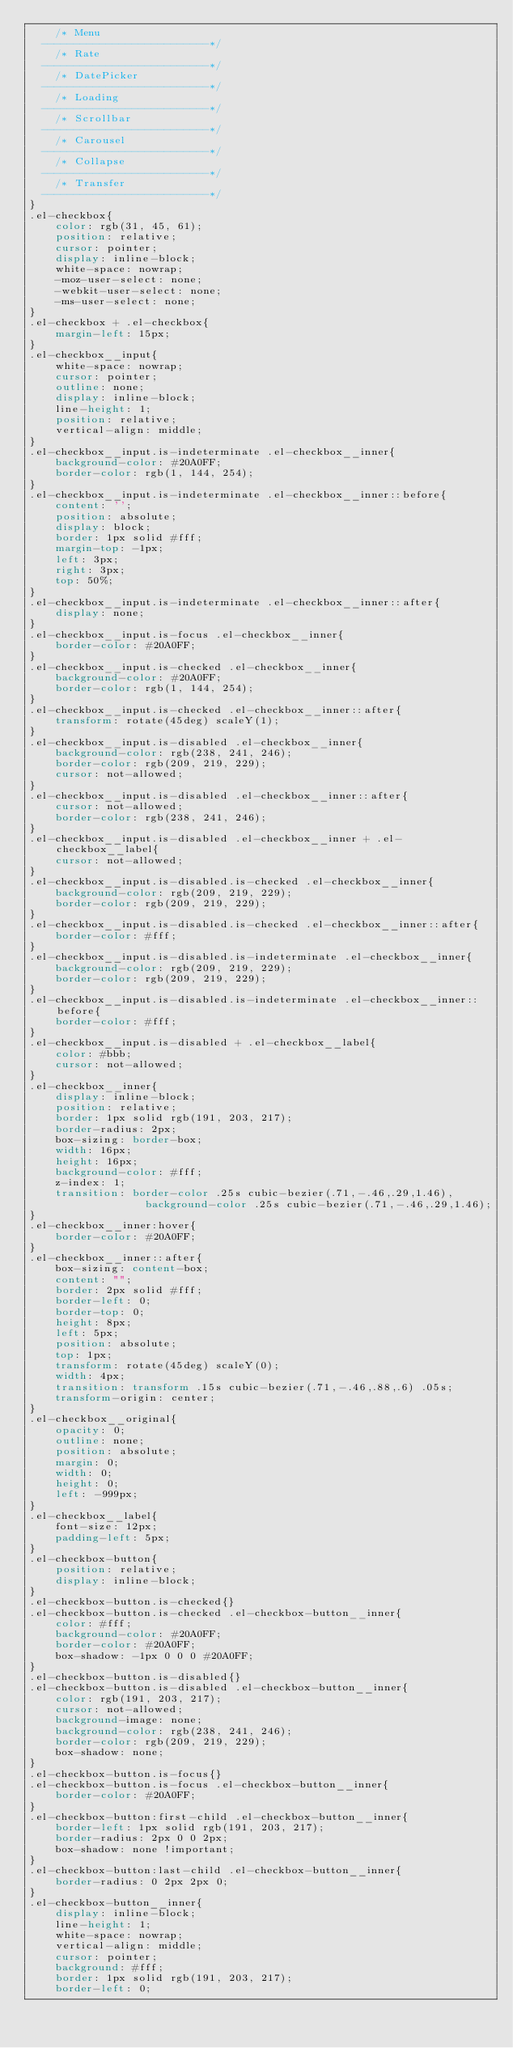<code> <loc_0><loc_0><loc_500><loc_500><_CSS_>    /* Menu
  --------------------------*/
    /* Rate
  --------------------------*/
    /* DatePicker
  --------------------------*/
    /* Loading
  --------------------------*/
    /* Scrollbar
  --------------------------*/
    /* Carousel
  --------------------------*/
    /* Collapse
  --------------------------*/
    /* Transfer
  --------------------------*/
}
.el-checkbox{
    color: rgb(31, 45, 61);
    position: relative;
    cursor: pointer;
    display: inline-block;
    white-space: nowrap;
    -moz-user-select: none;
    -webkit-user-select: none;
    -ms-user-select: none;
}
.el-checkbox + .el-checkbox{
    margin-left: 15px;
}
.el-checkbox__input{
    white-space: nowrap;
    cursor: pointer;
    outline: none;
    display: inline-block;
    line-height: 1;
    position: relative;
    vertical-align: middle;
}
.el-checkbox__input.is-indeterminate .el-checkbox__inner{
    background-color: #20A0FF;
    border-color: rgb(1, 144, 254);
}
.el-checkbox__input.is-indeterminate .el-checkbox__inner::before{
    content: '';
    position: absolute;
    display: block;
    border: 1px solid #fff;
    margin-top: -1px;
    left: 3px;
    right: 3px;
    top: 50%;
}
.el-checkbox__input.is-indeterminate .el-checkbox__inner::after{
    display: none;
}
.el-checkbox__input.is-focus .el-checkbox__inner{
    border-color: #20A0FF;
}
.el-checkbox__input.is-checked .el-checkbox__inner{
    background-color: #20A0FF;
    border-color: rgb(1, 144, 254);
}
.el-checkbox__input.is-checked .el-checkbox__inner::after{
    transform: rotate(45deg) scaleY(1);
}
.el-checkbox__input.is-disabled .el-checkbox__inner{
    background-color: rgb(238, 241, 246);
    border-color: rgb(209, 219, 229);
    cursor: not-allowed;
}
.el-checkbox__input.is-disabled .el-checkbox__inner::after{
    cursor: not-allowed;
    border-color: rgb(238, 241, 246);
}
.el-checkbox__input.is-disabled .el-checkbox__inner + .el-checkbox__label{
    cursor: not-allowed;
}
.el-checkbox__input.is-disabled.is-checked .el-checkbox__inner{
    background-color: rgb(209, 219, 229);
    border-color: rgb(209, 219, 229);
}
.el-checkbox__input.is-disabled.is-checked .el-checkbox__inner::after{
    border-color: #fff;
}
.el-checkbox__input.is-disabled.is-indeterminate .el-checkbox__inner{
    background-color: rgb(209, 219, 229);
    border-color: rgb(209, 219, 229);
}
.el-checkbox__input.is-disabled.is-indeterminate .el-checkbox__inner::before{
    border-color: #fff;
}
.el-checkbox__input.is-disabled + .el-checkbox__label{
    color: #bbb;
    cursor: not-allowed;
}
.el-checkbox__inner{
    display: inline-block;
    position: relative;
    border: 1px solid rgb(191, 203, 217);
    border-radius: 2px;
    box-sizing: border-box;
    width: 16px;
    height: 16px;
    background-color: #fff;
    z-index: 1;
    transition: border-color .25s cubic-bezier(.71,-.46,.29,1.46),
                  background-color .25s cubic-bezier(.71,-.46,.29,1.46);
}
.el-checkbox__inner:hover{
    border-color: #20A0FF;
}
.el-checkbox__inner::after{
    box-sizing: content-box;
    content: "";
    border: 2px solid #fff;
    border-left: 0;
    border-top: 0;
    height: 8px;
    left: 5px;
    position: absolute;
    top: 1px;
    transform: rotate(45deg) scaleY(0);
    width: 4px;
    transition: transform .15s cubic-bezier(.71,-.46,.88,.6) .05s;
    transform-origin: center;
}
.el-checkbox__original{
    opacity: 0;
    outline: none;
    position: absolute;
    margin: 0;
    width: 0;
    height: 0;
    left: -999px;
}
.el-checkbox__label{
    font-size: 12px;
    padding-left: 5px;
}
.el-checkbox-button{
    position: relative;
    display: inline-block;
}
.el-checkbox-button.is-checked{}
.el-checkbox-button.is-checked .el-checkbox-button__inner{
    color: #fff;
    background-color: #20A0FF;
    border-color: #20A0FF;
    box-shadow: -1px 0 0 0 #20A0FF;
}
.el-checkbox-button.is-disabled{}
.el-checkbox-button.is-disabled .el-checkbox-button__inner{
    color: rgb(191, 203, 217);
    cursor: not-allowed;
    background-image: none;
    background-color: rgb(238, 241, 246);
    border-color: rgb(209, 219, 229);
    box-shadow: none;
}
.el-checkbox-button.is-focus{}
.el-checkbox-button.is-focus .el-checkbox-button__inner{
    border-color: #20A0FF;
}
.el-checkbox-button:first-child .el-checkbox-button__inner{
    border-left: 1px solid rgb(191, 203, 217);
    border-radius: 2px 0 0 2px;
    box-shadow: none !important;
}
.el-checkbox-button:last-child .el-checkbox-button__inner{
    border-radius: 0 2px 2px 0;
}
.el-checkbox-button__inner{
    display: inline-block;
    line-height: 1;
    white-space: nowrap;
    vertical-align: middle;
    cursor: pointer;
    background: #fff;
    border: 1px solid rgb(191, 203, 217);
    border-left: 0;</code> 